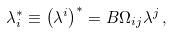Convert formula to latex. <formula><loc_0><loc_0><loc_500><loc_500>\lambda ^ { * } _ { i } \equiv \left ( \lambda ^ { i } \right ) ^ { * } = B \Omega _ { i j } \lambda ^ { j } \, ,</formula> 